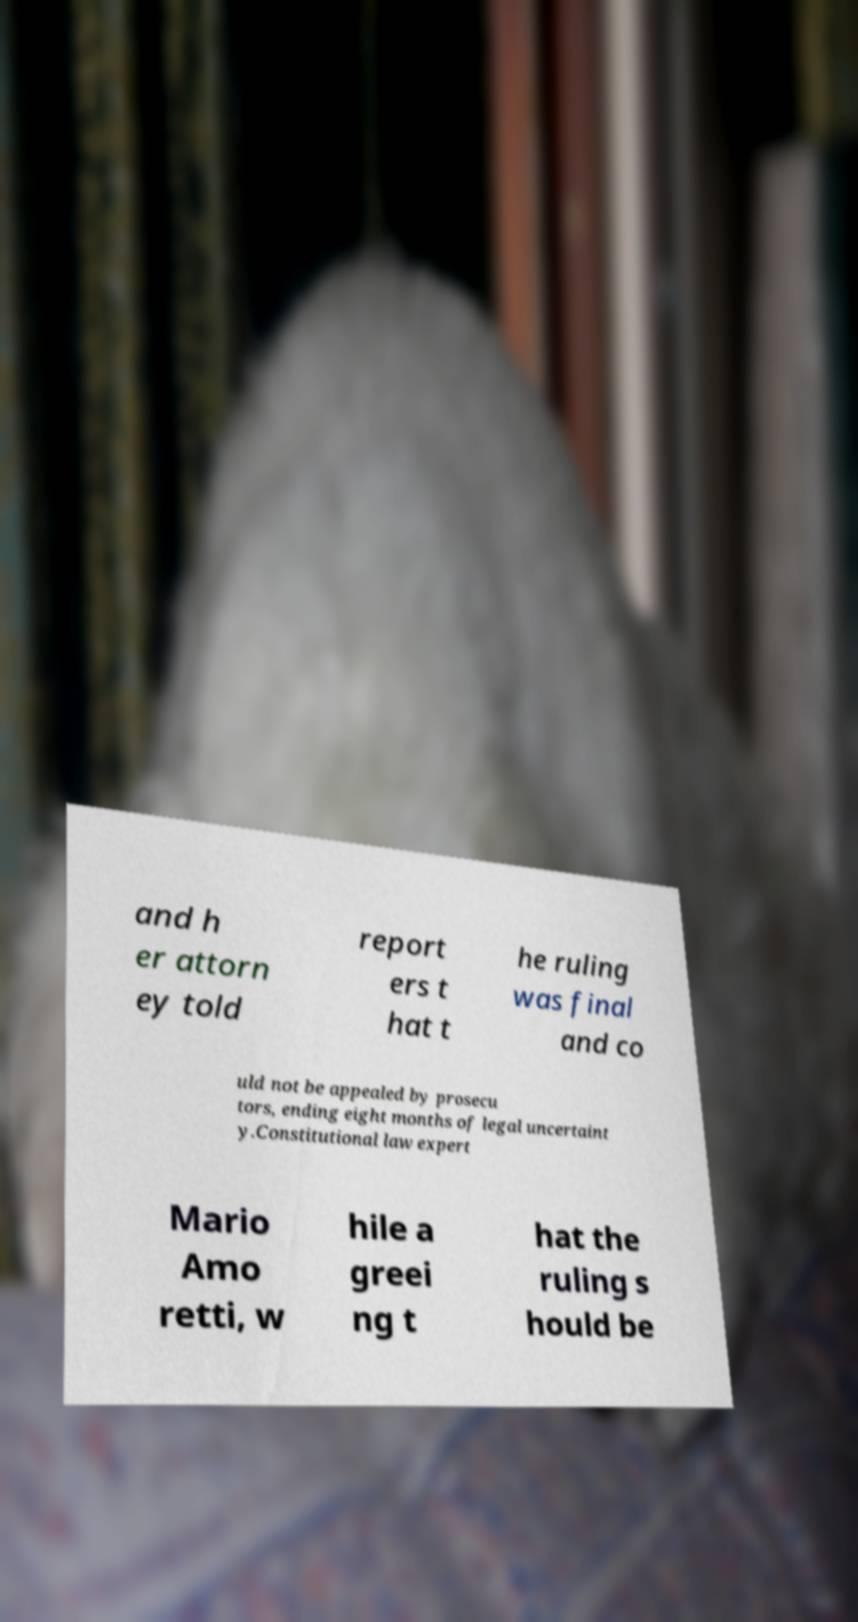Can you accurately transcribe the text from the provided image for me? and h er attorn ey told report ers t hat t he ruling was final and co uld not be appealed by prosecu tors, ending eight months of legal uncertaint y.Constitutional law expert Mario Amo retti, w hile a greei ng t hat the ruling s hould be 